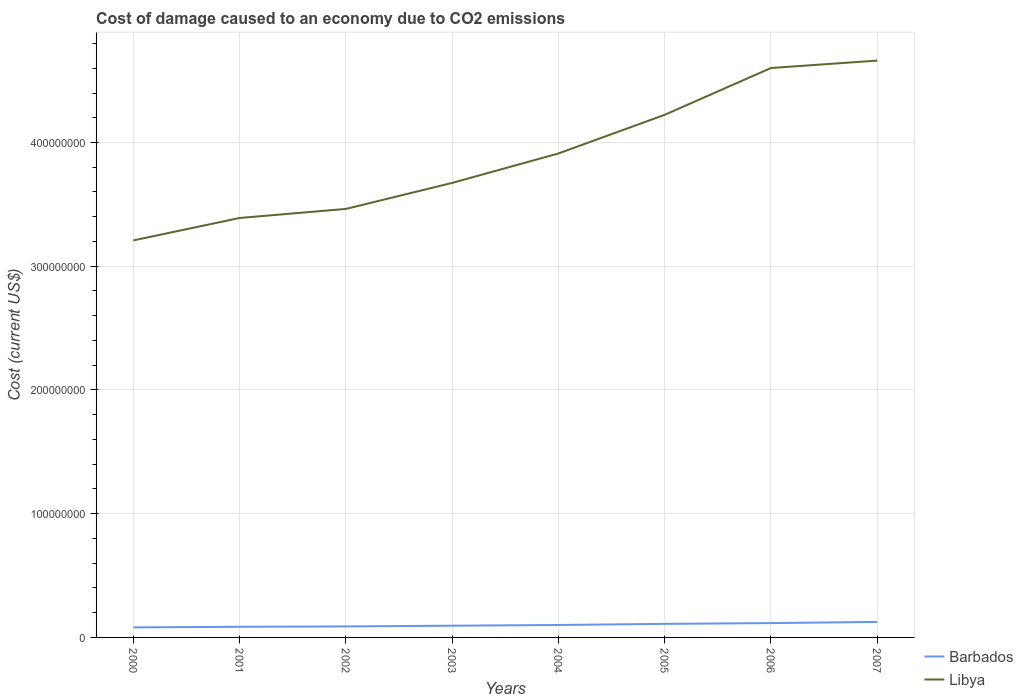How many different coloured lines are there?
Offer a terse response. 2. Is the number of lines equal to the number of legend labels?
Keep it short and to the point. Yes. Across all years, what is the maximum cost of damage caused due to CO2 emissisons in Barbados?
Ensure brevity in your answer.  8.09e+06. In which year was the cost of damage caused due to CO2 emissisons in Barbados maximum?
Offer a very short reply. 2000. What is the total cost of damage caused due to CO2 emissisons in Libya in the graph?
Your answer should be compact. -7.31e+06. What is the difference between the highest and the second highest cost of damage caused due to CO2 emissisons in Barbados?
Give a very brief answer. 4.43e+06. Is the cost of damage caused due to CO2 emissisons in Libya strictly greater than the cost of damage caused due to CO2 emissisons in Barbados over the years?
Make the answer very short. No. How many years are there in the graph?
Provide a succinct answer. 8. What is the difference between two consecutive major ticks on the Y-axis?
Make the answer very short. 1.00e+08. Are the values on the major ticks of Y-axis written in scientific E-notation?
Keep it short and to the point. No. Where does the legend appear in the graph?
Keep it short and to the point. Bottom right. How many legend labels are there?
Ensure brevity in your answer.  2. What is the title of the graph?
Offer a very short reply. Cost of damage caused to an economy due to CO2 emissions. What is the label or title of the Y-axis?
Make the answer very short. Cost (current US$). What is the Cost (current US$) in Barbados in 2000?
Give a very brief answer. 8.09e+06. What is the Cost (current US$) of Libya in 2000?
Ensure brevity in your answer.  3.21e+08. What is the Cost (current US$) in Barbados in 2001?
Provide a succinct answer. 8.61e+06. What is the Cost (current US$) in Libya in 2001?
Ensure brevity in your answer.  3.39e+08. What is the Cost (current US$) of Barbados in 2002?
Your answer should be compact. 8.89e+06. What is the Cost (current US$) of Libya in 2002?
Your answer should be very brief. 3.46e+08. What is the Cost (current US$) of Barbados in 2003?
Offer a very short reply. 9.48e+06. What is the Cost (current US$) in Libya in 2003?
Make the answer very short. 3.67e+08. What is the Cost (current US$) of Barbados in 2004?
Keep it short and to the point. 1.01e+07. What is the Cost (current US$) in Libya in 2004?
Make the answer very short. 3.91e+08. What is the Cost (current US$) in Barbados in 2005?
Provide a succinct answer. 1.10e+07. What is the Cost (current US$) of Libya in 2005?
Offer a terse response. 4.22e+08. What is the Cost (current US$) of Barbados in 2006?
Your answer should be very brief. 1.16e+07. What is the Cost (current US$) in Libya in 2006?
Your answer should be compact. 4.60e+08. What is the Cost (current US$) of Barbados in 2007?
Offer a terse response. 1.25e+07. What is the Cost (current US$) of Libya in 2007?
Ensure brevity in your answer.  4.66e+08. Across all years, what is the maximum Cost (current US$) in Barbados?
Give a very brief answer. 1.25e+07. Across all years, what is the maximum Cost (current US$) of Libya?
Your response must be concise. 4.66e+08. Across all years, what is the minimum Cost (current US$) in Barbados?
Ensure brevity in your answer.  8.09e+06. Across all years, what is the minimum Cost (current US$) of Libya?
Your answer should be very brief. 3.21e+08. What is the total Cost (current US$) in Barbados in the graph?
Your answer should be very brief. 8.02e+07. What is the total Cost (current US$) of Libya in the graph?
Your answer should be very brief. 3.11e+09. What is the difference between the Cost (current US$) of Barbados in 2000 and that in 2001?
Your response must be concise. -5.14e+05. What is the difference between the Cost (current US$) of Libya in 2000 and that in 2001?
Offer a very short reply. -1.81e+07. What is the difference between the Cost (current US$) in Barbados in 2000 and that in 2002?
Ensure brevity in your answer.  -8.02e+05. What is the difference between the Cost (current US$) in Libya in 2000 and that in 2002?
Provide a short and direct response. -2.54e+07. What is the difference between the Cost (current US$) in Barbados in 2000 and that in 2003?
Offer a terse response. -1.39e+06. What is the difference between the Cost (current US$) of Libya in 2000 and that in 2003?
Your response must be concise. -4.65e+07. What is the difference between the Cost (current US$) of Barbados in 2000 and that in 2004?
Ensure brevity in your answer.  -1.96e+06. What is the difference between the Cost (current US$) of Libya in 2000 and that in 2004?
Make the answer very short. -7.03e+07. What is the difference between the Cost (current US$) in Barbados in 2000 and that in 2005?
Your response must be concise. -2.88e+06. What is the difference between the Cost (current US$) in Libya in 2000 and that in 2005?
Give a very brief answer. -1.01e+08. What is the difference between the Cost (current US$) in Barbados in 2000 and that in 2006?
Offer a very short reply. -3.49e+06. What is the difference between the Cost (current US$) of Libya in 2000 and that in 2006?
Ensure brevity in your answer.  -1.39e+08. What is the difference between the Cost (current US$) in Barbados in 2000 and that in 2007?
Your response must be concise. -4.43e+06. What is the difference between the Cost (current US$) of Libya in 2000 and that in 2007?
Ensure brevity in your answer.  -1.45e+08. What is the difference between the Cost (current US$) in Barbados in 2001 and that in 2002?
Your answer should be very brief. -2.88e+05. What is the difference between the Cost (current US$) of Libya in 2001 and that in 2002?
Keep it short and to the point. -7.31e+06. What is the difference between the Cost (current US$) in Barbados in 2001 and that in 2003?
Make the answer very short. -8.73e+05. What is the difference between the Cost (current US$) in Libya in 2001 and that in 2003?
Provide a short and direct response. -2.83e+07. What is the difference between the Cost (current US$) in Barbados in 2001 and that in 2004?
Your answer should be very brief. -1.45e+06. What is the difference between the Cost (current US$) in Libya in 2001 and that in 2004?
Offer a very short reply. -5.21e+07. What is the difference between the Cost (current US$) of Barbados in 2001 and that in 2005?
Offer a very short reply. -2.36e+06. What is the difference between the Cost (current US$) in Libya in 2001 and that in 2005?
Offer a very short reply. -8.34e+07. What is the difference between the Cost (current US$) in Barbados in 2001 and that in 2006?
Your response must be concise. -2.97e+06. What is the difference between the Cost (current US$) in Libya in 2001 and that in 2006?
Give a very brief answer. -1.21e+08. What is the difference between the Cost (current US$) of Barbados in 2001 and that in 2007?
Provide a short and direct response. -3.92e+06. What is the difference between the Cost (current US$) of Libya in 2001 and that in 2007?
Keep it short and to the point. -1.27e+08. What is the difference between the Cost (current US$) in Barbados in 2002 and that in 2003?
Ensure brevity in your answer.  -5.85e+05. What is the difference between the Cost (current US$) of Libya in 2002 and that in 2003?
Offer a very short reply. -2.10e+07. What is the difference between the Cost (current US$) of Barbados in 2002 and that in 2004?
Provide a short and direct response. -1.16e+06. What is the difference between the Cost (current US$) in Libya in 2002 and that in 2004?
Make the answer very short. -4.48e+07. What is the difference between the Cost (current US$) in Barbados in 2002 and that in 2005?
Offer a terse response. -2.07e+06. What is the difference between the Cost (current US$) of Libya in 2002 and that in 2005?
Your answer should be compact. -7.60e+07. What is the difference between the Cost (current US$) in Barbados in 2002 and that in 2006?
Provide a succinct answer. -2.68e+06. What is the difference between the Cost (current US$) of Libya in 2002 and that in 2006?
Ensure brevity in your answer.  -1.14e+08. What is the difference between the Cost (current US$) of Barbados in 2002 and that in 2007?
Offer a terse response. -3.63e+06. What is the difference between the Cost (current US$) of Libya in 2002 and that in 2007?
Your answer should be very brief. -1.20e+08. What is the difference between the Cost (current US$) of Barbados in 2003 and that in 2004?
Provide a short and direct response. -5.74e+05. What is the difference between the Cost (current US$) in Libya in 2003 and that in 2004?
Your answer should be very brief. -2.38e+07. What is the difference between the Cost (current US$) of Barbados in 2003 and that in 2005?
Your response must be concise. -1.49e+06. What is the difference between the Cost (current US$) of Libya in 2003 and that in 2005?
Provide a succinct answer. -5.50e+07. What is the difference between the Cost (current US$) in Barbados in 2003 and that in 2006?
Give a very brief answer. -2.10e+06. What is the difference between the Cost (current US$) of Libya in 2003 and that in 2006?
Provide a short and direct response. -9.28e+07. What is the difference between the Cost (current US$) of Barbados in 2003 and that in 2007?
Give a very brief answer. -3.05e+06. What is the difference between the Cost (current US$) of Libya in 2003 and that in 2007?
Your answer should be compact. -9.89e+07. What is the difference between the Cost (current US$) of Barbados in 2004 and that in 2005?
Give a very brief answer. -9.14e+05. What is the difference between the Cost (current US$) in Libya in 2004 and that in 2005?
Offer a terse response. -3.12e+07. What is the difference between the Cost (current US$) of Barbados in 2004 and that in 2006?
Ensure brevity in your answer.  -1.52e+06. What is the difference between the Cost (current US$) of Libya in 2004 and that in 2006?
Offer a terse response. -6.91e+07. What is the difference between the Cost (current US$) of Barbados in 2004 and that in 2007?
Your answer should be compact. -2.47e+06. What is the difference between the Cost (current US$) in Libya in 2004 and that in 2007?
Ensure brevity in your answer.  -7.51e+07. What is the difference between the Cost (current US$) of Barbados in 2005 and that in 2006?
Provide a short and direct response. -6.11e+05. What is the difference between the Cost (current US$) in Libya in 2005 and that in 2006?
Ensure brevity in your answer.  -3.78e+07. What is the difference between the Cost (current US$) of Barbados in 2005 and that in 2007?
Ensure brevity in your answer.  -1.56e+06. What is the difference between the Cost (current US$) in Libya in 2005 and that in 2007?
Provide a short and direct response. -4.38e+07. What is the difference between the Cost (current US$) in Barbados in 2006 and that in 2007?
Offer a terse response. -9.47e+05. What is the difference between the Cost (current US$) in Libya in 2006 and that in 2007?
Your answer should be very brief. -6.00e+06. What is the difference between the Cost (current US$) of Barbados in 2000 and the Cost (current US$) of Libya in 2001?
Your answer should be very brief. -3.31e+08. What is the difference between the Cost (current US$) in Barbados in 2000 and the Cost (current US$) in Libya in 2002?
Provide a short and direct response. -3.38e+08. What is the difference between the Cost (current US$) of Barbados in 2000 and the Cost (current US$) of Libya in 2003?
Ensure brevity in your answer.  -3.59e+08. What is the difference between the Cost (current US$) of Barbados in 2000 and the Cost (current US$) of Libya in 2004?
Keep it short and to the point. -3.83e+08. What is the difference between the Cost (current US$) in Barbados in 2000 and the Cost (current US$) in Libya in 2005?
Provide a succinct answer. -4.14e+08. What is the difference between the Cost (current US$) of Barbados in 2000 and the Cost (current US$) of Libya in 2006?
Give a very brief answer. -4.52e+08. What is the difference between the Cost (current US$) in Barbados in 2000 and the Cost (current US$) in Libya in 2007?
Your answer should be very brief. -4.58e+08. What is the difference between the Cost (current US$) of Barbados in 2001 and the Cost (current US$) of Libya in 2002?
Your response must be concise. -3.38e+08. What is the difference between the Cost (current US$) of Barbados in 2001 and the Cost (current US$) of Libya in 2003?
Provide a short and direct response. -3.59e+08. What is the difference between the Cost (current US$) of Barbados in 2001 and the Cost (current US$) of Libya in 2004?
Your response must be concise. -3.83e+08. What is the difference between the Cost (current US$) in Barbados in 2001 and the Cost (current US$) in Libya in 2005?
Keep it short and to the point. -4.14e+08. What is the difference between the Cost (current US$) of Barbados in 2001 and the Cost (current US$) of Libya in 2006?
Give a very brief answer. -4.52e+08. What is the difference between the Cost (current US$) of Barbados in 2001 and the Cost (current US$) of Libya in 2007?
Offer a very short reply. -4.58e+08. What is the difference between the Cost (current US$) of Barbados in 2002 and the Cost (current US$) of Libya in 2003?
Keep it short and to the point. -3.58e+08. What is the difference between the Cost (current US$) of Barbados in 2002 and the Cost (current US$) of Libya in 2004?
Your response must be concise. -3.82e+08. What is the difference between the Cost (current US$) of Barbados in 2002 and the Cost (current US$) of Libya in 2005?
Keep it short and to the point. -4.13e+08. What is the difference between the Cost (current US$) of Barbados in 2002 and the Cost (current US$) of Libya in 2006?
Your response must be concise. -4.51e+08. What is the difference between the Cost (current US$) of Barbados in 2002 and the Cost (current US$) of Libya in 2007?
Make the answer very short. -4.57e+08. What is the difference between the Cost (current US$) in Barbados in 2003 and the Cost (current US$) in Libya in 2004?
Ensure brevity in your answer.  -3.82e+08. What is the difference between the Cost (current US$) of Barbados in 2003 and the Cost (current US$) of Libya in 2005?
Your answer should be compact. -4.13e+08. What is the difference between the Cost (current US$) of Barbados in 2003 and the Cost (current US$) of Libya in 2006?
Offer a very short reply. -4.51e+08. What is the difference between the Cost (current US$) in Barbados in 2003 and the Cost (current US$) in Libya in 2007?
Provide a succinct answer. -4.57e+08. What is the difference between the Cost (current US$) in Barbados in 2004 and the Cost (current US$) in Libya in 2005?
Ensure brevity in your answer.  -4.12e+08. What is the difference between the Cost (current US$) in Barbados in 2004 and the Cost (current US$) in Libya in 2006?
Your response must be concise. -4.50e+08. What is the difference between the Cost (current US$) in Barbados in 2004 and the Cost (current US$) in Libya in 2007?
Make the answer very short. -4.56e+08. What is the difference between the Cost (current US$) of Barbados in 2005 and the Cost (current US$) of Libya in 2006?
Your answer should be compact. -4.49e+08. What is the difference between the Cost (current US$) of Barbados in 2005 and the Cost (current US$) of Libya in 2007?
Give a very brief answer. -4.55e+08. What is the difference between the Cost (current US$) of Barbados in 2006 and the Cost (current US$) of Libya in 2007?
Offer a very short reply. -4.55e+08. What is the average Cost (current US$) in Barbados per year?
Your response must be concise. 1.00e+07. What is the average Cost (current US$) in Libya per year?
Provide a succinct answer. 3.89e+08. In the year 2000, what is the difference between the Cost (current US$) in Barbados and Cost (current US$) in Libya?
Give a very brief answer. -3.13e+08. In the year 2001, what is the difference between the Cost (current US$) of Barbados and Cost (current US$) of Libya?
Provide a short and direct response. -3.30e+08. In the year 2002, what is the difference between the Cost (current US$) in Barbados and Cost (current US$) in Libya?
Give a very brief answer. -3.37e+08. In the year 2003, what is the difference between the Cost (current US$) of Barbados and Cost (current US$) of Libya?
Provide a short and direct response. -3.58e+08. In the year 2004, what is the difference between the Cost (current US$) in Barbados and Cost (current US$) in Libya?
Provide a short and direct response. -3.81e+08. In the year 2005, what is the difference between the Cost (current US$) of Barbados and Cost (current US$) of Libya?
Offer a very short reply. -4.11e+08. In the year 2006, what is the difference between the Cost (current US$) of Barbados and Cost (current US$) of Libya?
Provide a succinct answer. -4.49e+08. In the year 2007, what is the difference between the Cost (current US$) of Barbados and Cost (current US$) of Libya?
Offer a terse response. -4.54e+08. What is the ratio of the Cost (current US$) of Barbados in 2000 to that in 2001?
Your answer should be compact. 0.94. What is the ratio of the Cost (current US$) of Libya in 2000 to that in 2001?
Ensure brevity in your answer.  0.95. What is the ratio of the Cost (current US$) of Barbados in 2000 to that in 2002?
Make the answer very short. 0.91. What is the ratio of the Cost (current US$) of Libya in 2000 to that in 2002?
Make the answer very short. 0.93. What is the ratio of the Cost (current US$) of Barbados in 2000 to that in 2003?
Provide a succinct answer. 0.85. What is the ratio of the Cost (current US$) in Libya in 2000 to that in 2003?
Keep it short and to the point. 0.87. What is the ratio of the Cost (current US$) of Barbados in 2000 to that in 2004?
Ensure brevity in your answer.  0.8. What is the ratio of the Cost (current US$) in Libya in 2000 to that in 2004?
Your answer should be compact. 0.82. What is the ratio of the Cost (current US$) in Barbados in 2000 to that in 2005?
Offer a very short reply. 0.74. What is the ratio of the Cost (current US$) in Libya in 2000 to that in 2005?
Offer a very short reply. 0.76. What is the ratio of the Cost (current US$) in Barbados in 2000 to that in 2006?
Give a very brief answer. 0.7. What is the ratio of the Cost (current US$) of Libya in 2000 to that in 2006?
Make the answer very short. 0.7. What is the ratio of the Cost (current US$) of Barbados in 2000 to that in 2007?
Make the answer very short. 0.65. What is the ratio of the Cost (current US$) of Libya in 2000 to that in 2007?
Your answer should be very brief. 0.69. What is the ratio of the Cost (current US$) of Barbados in 2001 to that in 2002?
Provide a short and direct response. 0.97. What is the ratio of the Cost (current US$) of Libya in 2001 to that in 2002?
Your answer should be compact. 0.98. What is the ratio of the Cost (current US$) in Barbados in 2001 to that in 2003?
Your answer should be very brief. 0.91. What is the ratio of the Cost (current US$) in Libya in 2001 to that in 2003?
Keep it short and to the point. 0.92. What is the ratio of the Cost (current US$) of Barbados in 2001 to that in 2004?
Provide a short and direct response. 0.86. What is the ratio of the Cost (current US$) in Libya in 2001 to that in 2004?
Keep it short and to the point. 0.87. What is the ratio of the Cost (current US$) in Barbados in 2001 to that in 2005?
Give a very brief answer. 0.78. What is the ratio of the Cost (current US$) of Libya in 2001 to that in 2005?
Provide a short and direct response. 0.8. What is the ratio of the Cost (current US$) in Barbados in 2001 to that in 2006?
Provide a short and direct response. 0.74. What is the ratio of the Cost (current US$) in Libya in 2001 to that in 2006?
Offer a very short reply. 0.74. What is the ratio of the Cost (current US$) of Barbados in 2001 to that in 2007?
Your answer should be compact. 0.69. What is the ratio of the Cost (current US$) of Libya in 2001 to that in 2007?
Your answer should be compact. 0.73. What is the ratio of the Cost (current US$) of Barbados in 2002 to that in 2003?
Offer a terse response. 0.94. What is the ratio of the Cost (current US$) of Libya in 2002 to that in 2003?
Make the answer very short. 0.94. What is the ratio of the Cost (current US$) in Barbados in 2002 to that in 2004?
Provide a short and direct response. 0.88. What is the ratio of the Cost (current US$) in Libya in 2002 to that in 2004?
Provide a short and direct response. 0.89. What is the ratio of the Cost (current US$) of Barbados in 2002 to that in 2005?
Offer a terse response. 0.81. What is the ratio of the Cost (current US$) in Libya in 2002 to that in 2005?
Offer a very short reply. 0.82. What is the ratio of the Cost (current US$) in Barbados in 2002 to that in 2006?
Your answer should be compact. 0.77. What is the ratio of the Cost (current US$) of Libya in 2002 to that in 2006?
Provide a succinct answer. 0.75. What is the ratio of the Cost (current US$) of Barbados in 2002 to that in 2007?
Ensure brevity in your answer.  0.71. What is the ratio of the Cost (current US$) of Libya in 2002 to that in 2007?
Give a very brief answer. 0.74. What is the ratio of the Cost (current US$) of Barbados in 2003 to that in 2004?
Provide a short and direct response. 0.94. What is the ratio of the Cost (current US$) of Libya in 2003 to that in 2004?
Offer a very short reply. 0.94. What is the ratio of the Cost (current US$) of Barbados in 2003 to that in 2005?
Ensure brevity in your answer.  0.86. What is the ratio of the Cost (current US$) in Libya in 2003 to that in 2005?
Your response must be concise. 0.87. What is the ratio of the Cost (current US$) of Barbados in 2003 to that in 2006?
Make the answer very short. 0.82. What is the ratio of the Cost (current US$) of Libya in 2003 to that in 2006?
Provide a succinct answer. 0.8. What is the ratio of the Cost (current US$) in Barbados in 2003 to that in 2007?
Keep it short and to the point. 0.76. What is the ratio of the Cost (current US$) in Libya in 2003 to that in 2007?
Give a very brief answer. 0.79. What is the ratio of the Cost (current US$) of Barbados in 2004 to that in 2005?
Keep it short and to the point. 0.92. What is the ratio of the Cost (current US$) in Libya in 2004 to that in 2005?
Your answer should be compact. 0.93. What is the ratio of the Cost (current US$) in Barbados in 2004 to that in 2006?
Make the answer very short. 0.87. What is the ratio of the Cost (current US$) in Libya in 2004 to that in 2006?
Provide a short and direct response. 0.85. What is the ratio of the Cost (current US$) in Barbados in 2004 to that in 2007?
Offer a terse response. 0.8. What is the ratio of the Cost (current US$) in Libya in 2004 to that in 2007?
Make the answer very short. 0.84. What is the ratio of the Cost (current US$) in Barbados in 2005 to that in 2006?
Your answer should be very brief. 0.95. What is the ratio of the Cost (current US$) of Libya in 2005 to that in 2006?
Your answer should be compact. 0.92. What is the ratio of the Cost (current US$) in Barbados in 2005 to that in 2007?
Offer a very short reply. 0.88. What is the ratio of the Cost (current US$) of Libya in 2005 to that in 2007?
Your answer should be very brief. 0.91. What is the ratio of the Cost (current US$) of Barbados in 2006 to that in 2007?
Offer a very short reply. 0.92. What is the ratio of the Cost (current US$) of Libya in 2006 to that in 2007?
Make the answer very short. 0.99. What is the difference between the highest and the second highest Cost (current US$) of Barbados?
Make the answer very short. 9.47e+05. What is the difference between the highest and the second highest Cost (current US$) in Libya?
Give a very brief answer. 6.00e+06. What is the difference between the highest and the lowest Cost (current US$) of Barbados?
Provide a succinct answer. 4.43e+06. What is the difference between the highest and the lowest Cost (current US$) in Libya?
Your response must be concise. 1.45e+08. 